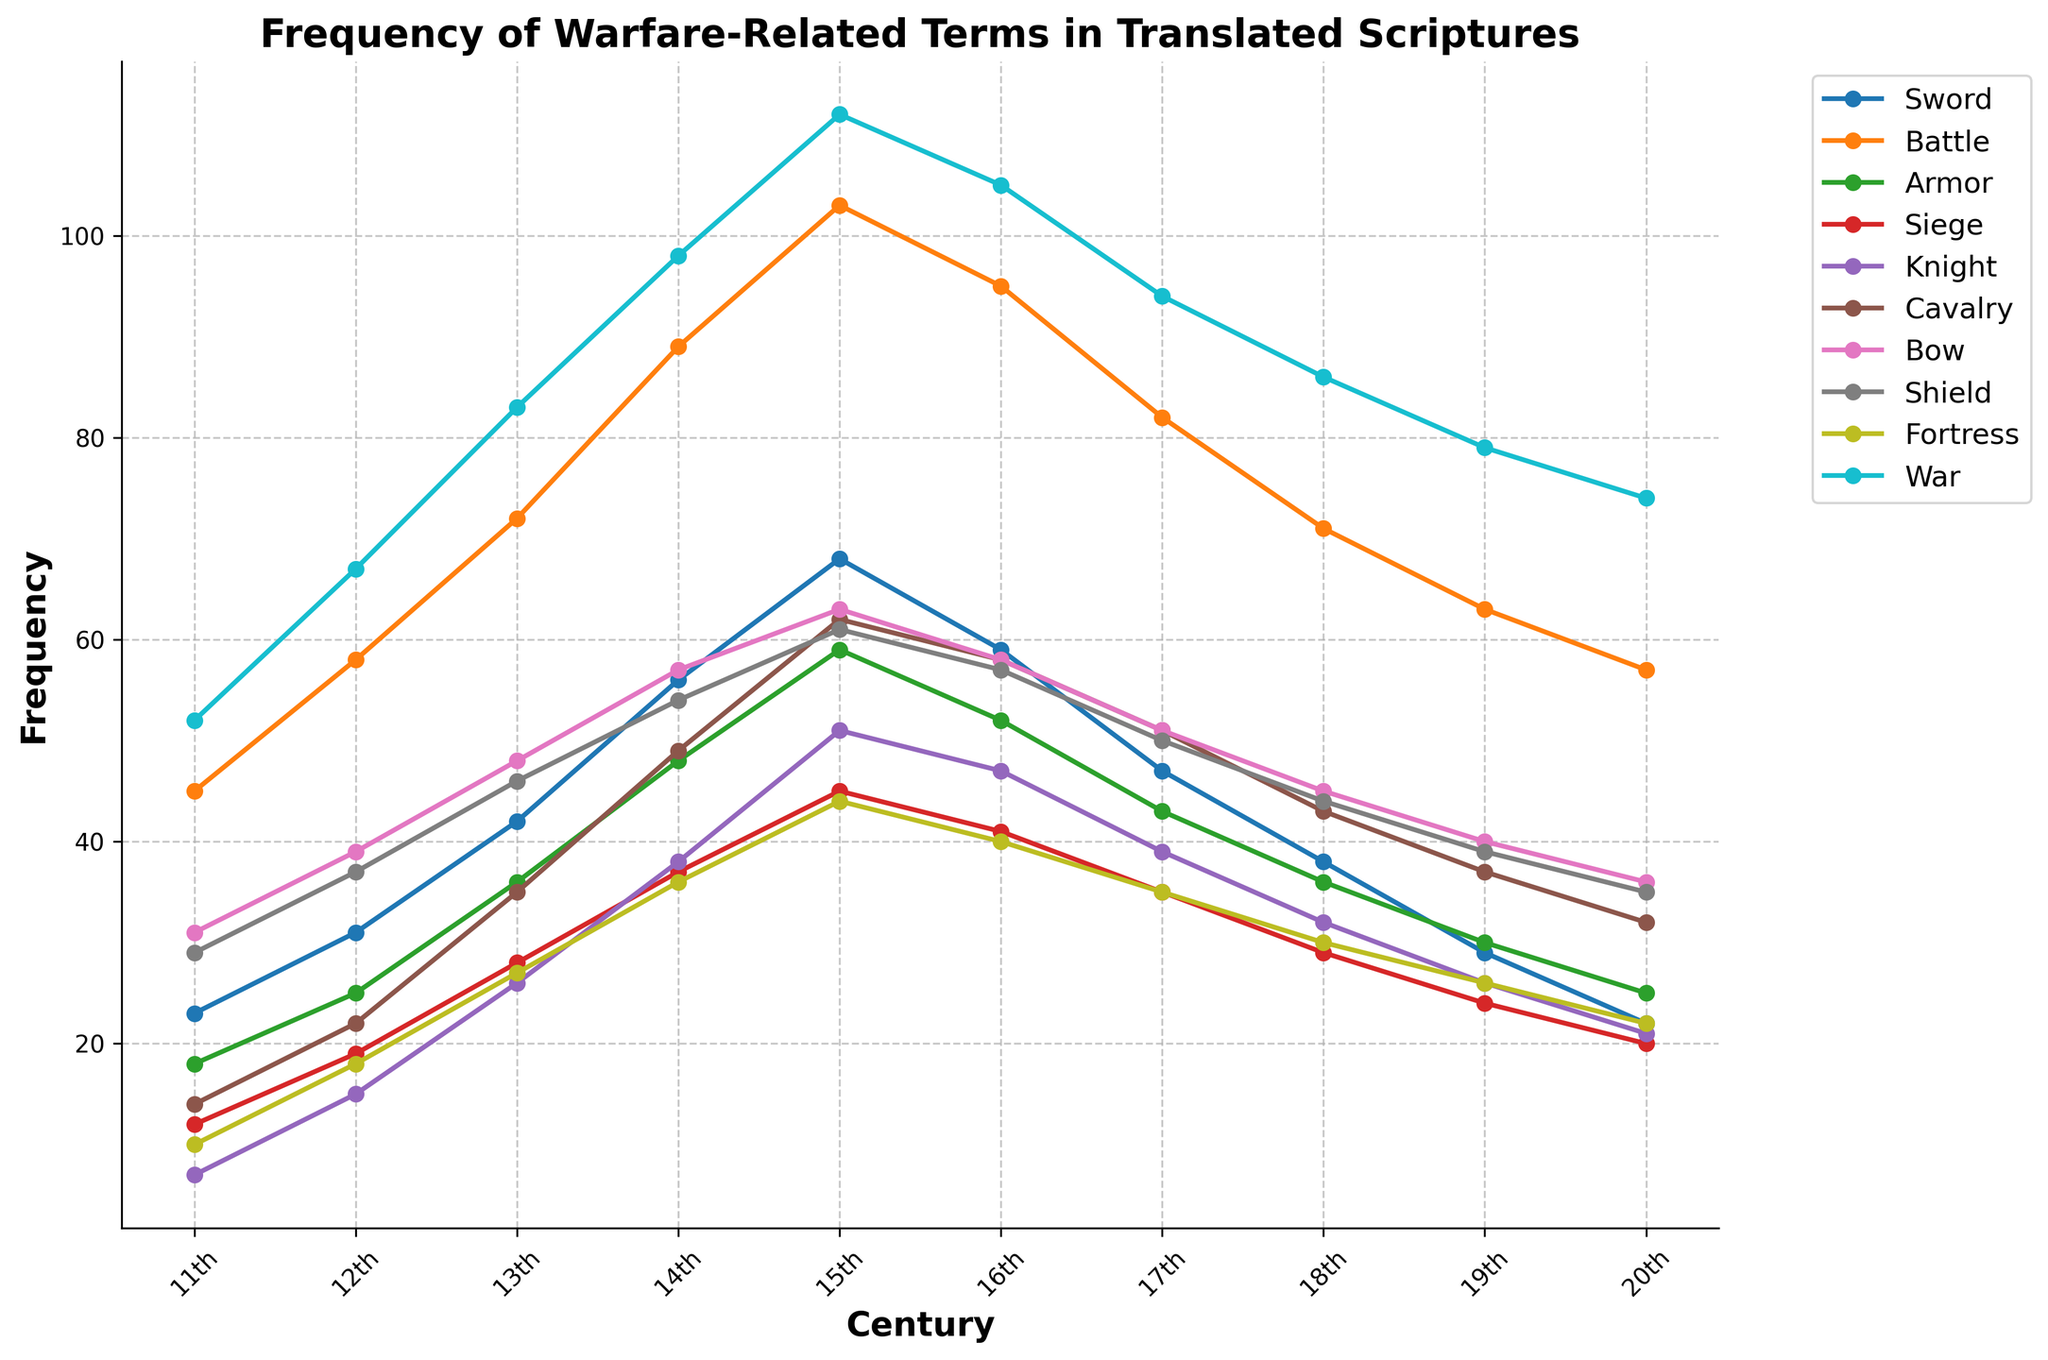What term saw the highest frequency in the 11th century? Looking at the line chart, identify which term has the highest y-value in the 11th century. "War" has the highest frequency with a value of 52.
Answer: War Which century saw the peak frequency of the term "Armor"? Observe the y-axis values of the line representing "Armor" and identify the century with the highest point. The 15th century saw the peak frequency of "Armor" with a value of 59.
Answer: 15th century Did the frequency of the term "Knight" increase or decrease from the 13th to the 14th century? Check the y-values corresponding to "Knight" in the 13th and 14th centuries. The value increased from 26 in the 13th century to 38 in the 14th century.
Answer: Increase How does the frequency of "Siege" in the 16th century compare to that in the 12th century? Find the y-values for "Siege" in the 12th and 16th centuries and compare them. The frequency increased from 19 in the 12th century to 41 in the 16th century.
Answer: Increased What is the combined frequency of the terms "Sword" and "Shield" in the 18th century? Add the y-values for "Sword" and "Shield" in the 18th century. "Sword" has a frequency of 38 and "Shield" has a frequency of 44, giving a combined frequency of 38 + 44 = 82.
Answer: 82 Between which two consecutive centuries did the term "Cavalry" see the greatest increase in frequency? Calculate the difference in frequencies for "Cavalry" between each pair of consecutive centuries and identify the highest. The greatest increase is between the 11th century (14) and the 12th century (22) with an increase of 8.
Answer: 11th to 12th century Which term had a declining frequency for most of the centuries shown? Track each term's line from the 11th to the 20th century and identify which one generally declines. "Siege" shows an overall declining trend.
Answer: Siege In which century did the term "Bow" reach its maximum frequency and what was it? Look for the peak value of the line representing "Bow" and note the century and value. The maximum frequency is in the 14th century with a value of 57.
Answer: 14th century, 57 How does the frequency of "Fortress" change from the 15th century to the 20th century? Compare the frequencies in the 15th century (44) with the 20th century (22). The frequency declines from 44 to 22.
Answer: Decline What is the average frequency of the term "Knight" from the 11th to the 15th century? Add the frequencies for "Knight" from the 11th to the 15th century (7, 15, 26, 38, 51) and divide by 5. The average is (7 + 15 + 26 + 38 + 51) / 5 = 27.4.
Answer: 27.4 